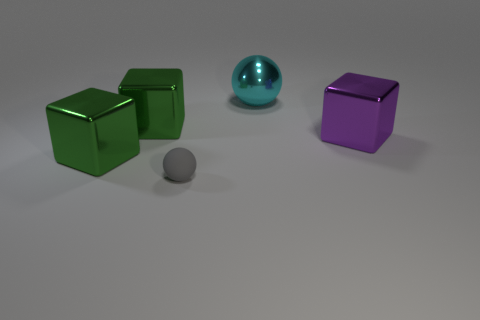Subtract all brown balls. How many green cubes are left? 2 Subtract all big purple metallic blocks. How many blocks are left? 2 Add 3 large balls. How many objects exist? 8 Subtract all balls. How many objects are left? 3 Subtract 0 brown blocks. How many objects are left? 5 Subtract all shiny blocks. Subtract all big purple metallic cubes. How many objects are left? 1 Add 4 blocks. How many blocks are left? 7 Add 3 large green shiny cubes. How many large green shiny cubes exist? 5 